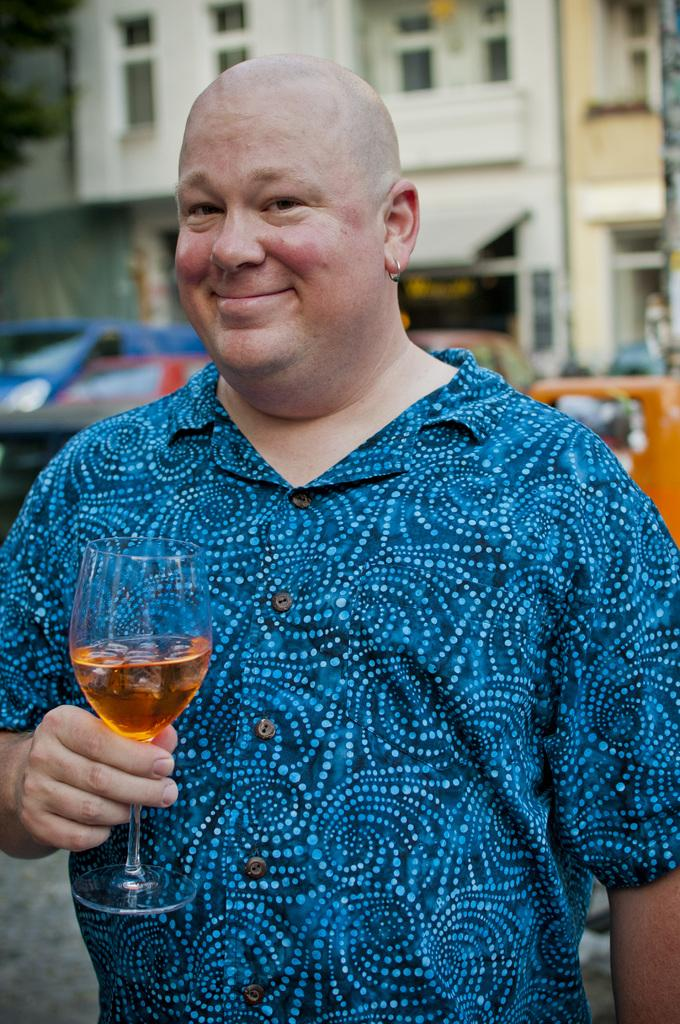Who is present in the image? There is a man in the image. What is the man wearing? The man is wearing a blue T-shirt. What is the man holding in his hand? The man is holding a glass in his hand. What can be seen in the background of the image? There is a car, a tree, and a building in the background of the image. What type of account does the man have in the image? There is no mention of an account in the image, so it cannot be determined. 